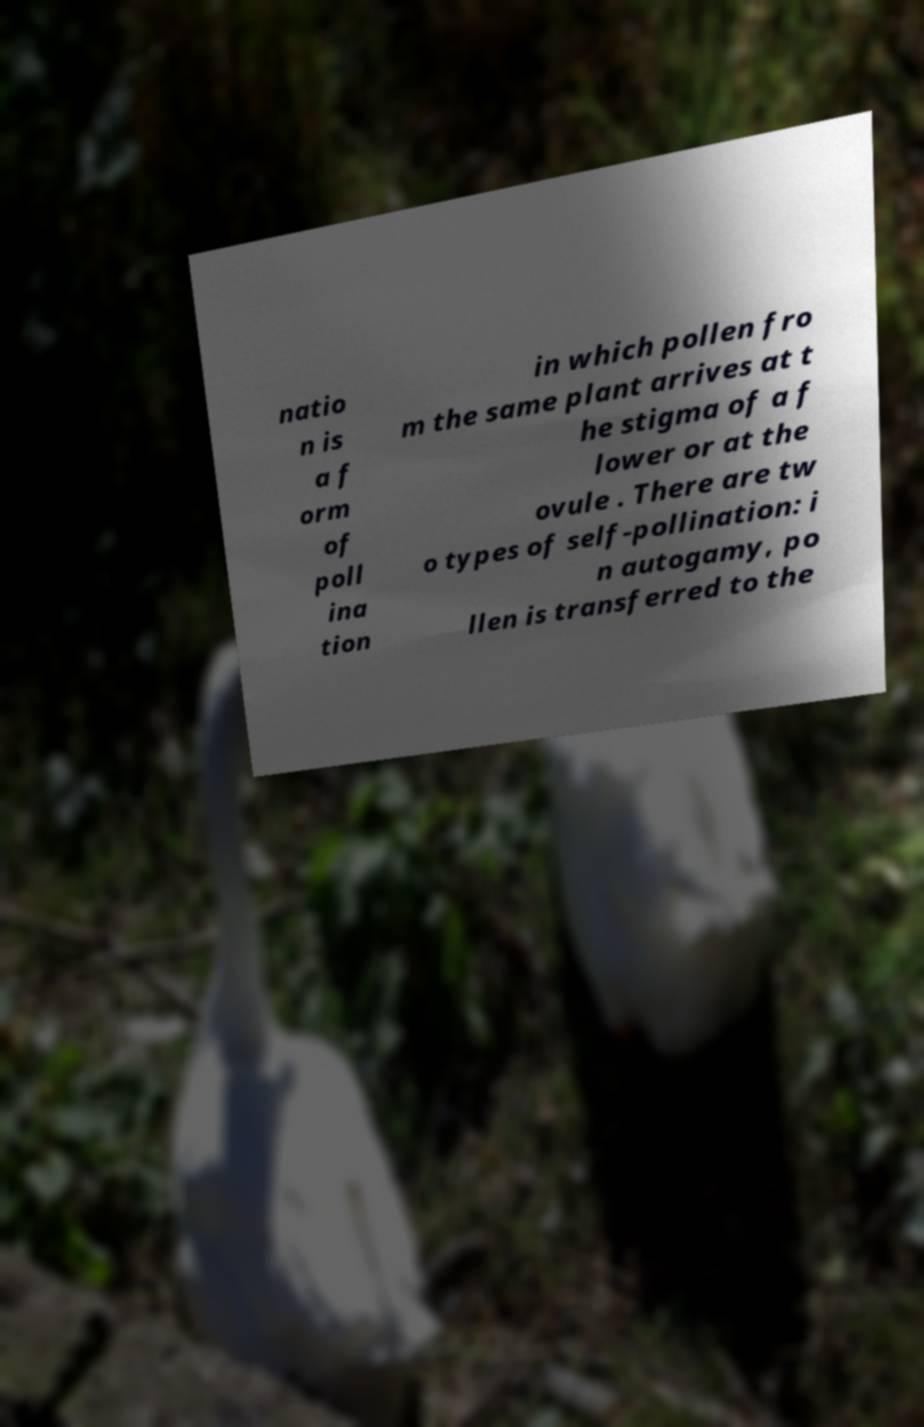Can you accurately transcribe the text from the provided image for me? natio n is a f orm of poll ina tion in which pollen fro m the same plant arrives at t he stigma of a f lower or at the ovule . There are tw o types of self-pollination: i n autogamy, po llen is transferred to the 